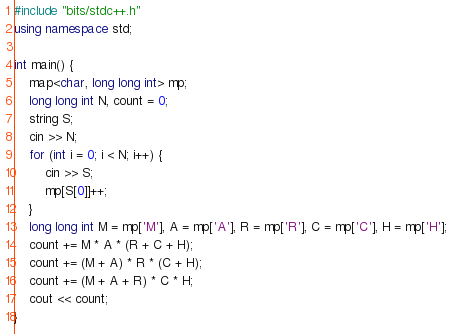Convert code to text. <code><loc_0><loc_0><loc_500><loc_500><_C++_>#include "bits/stdc++.h"
using namespace std;

int main() {
	map<char, long long int> mp;
	long long int N, count = 0;
	string S;
	cin >> N;
	for (int i = 0; i < N; i++) {
		cin >> S;
		mp[S[0]]++;
	}
	long long int M = mp['M'], A = mp['A'], R = mp['R'], C = mp['C'], H = mp['H'];
	count += M * A * (R + C + H);
	count += (M + A) * R * (C + H);
	count += (M + A + R) * C * H;
	cout << count;
}</code> 